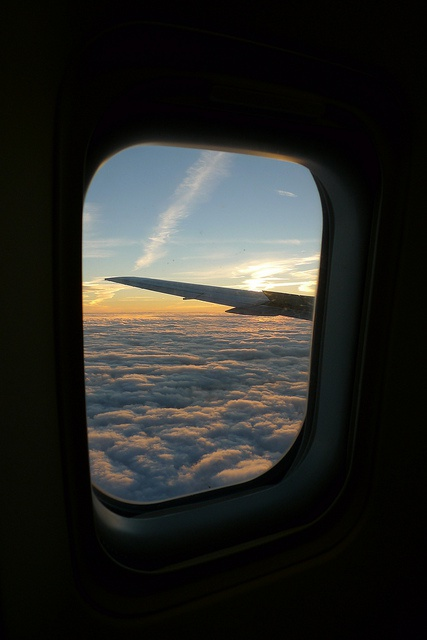Describe the objects in this image and their specific colors. I can see a airplane in black, purple, and khaki tones in this image. 